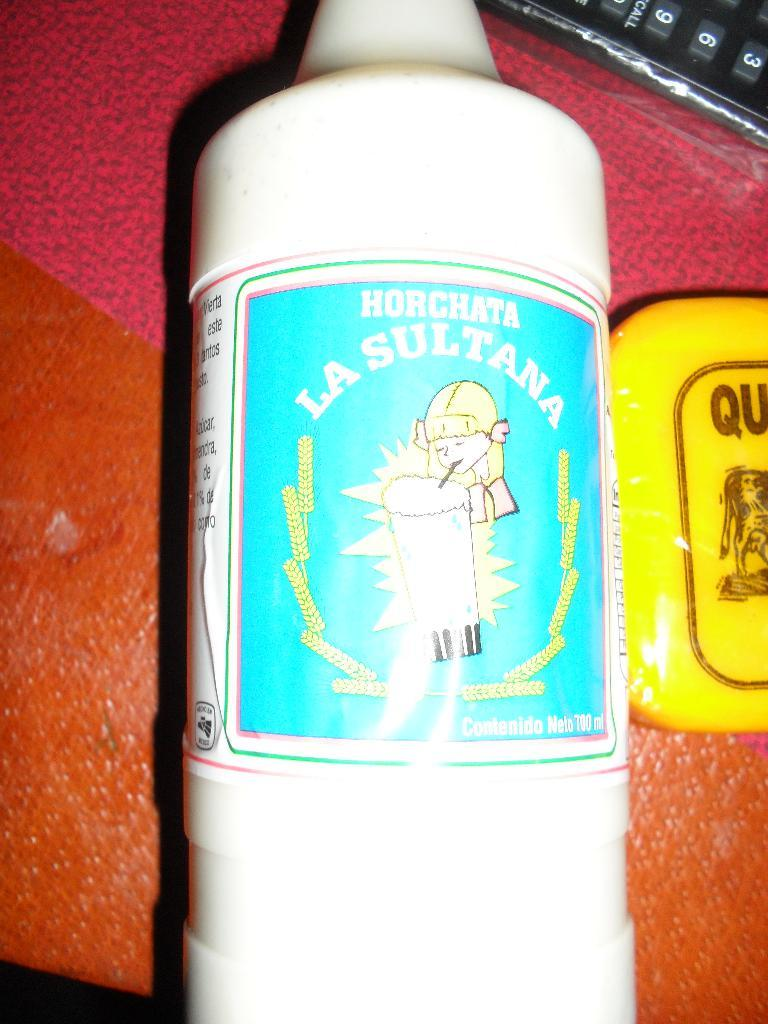<image>
Present a compact description of the photo's key features. A bottle is labelled Horchata from La Sultana. 